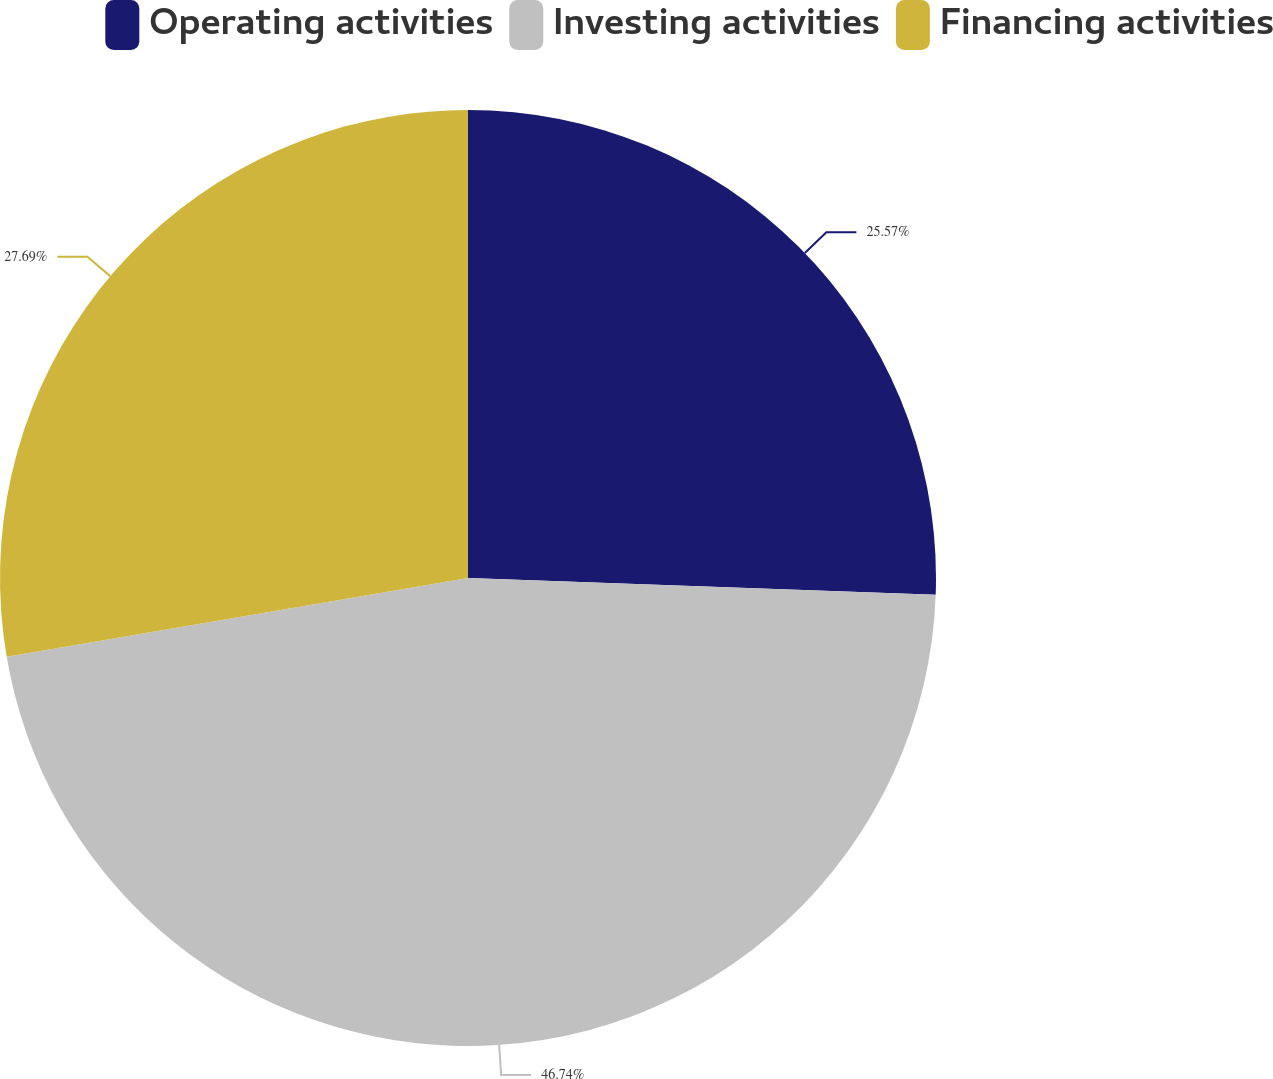<chart> <loc_0><loc_0><loc_500><loc_500><pie_chart><fcel>Operating activities<fcel>Investing activities<fcel>Financing activities<nl><fcel>25.57%<fcel>46.74%<fcel>27.69%<nl></chart> 